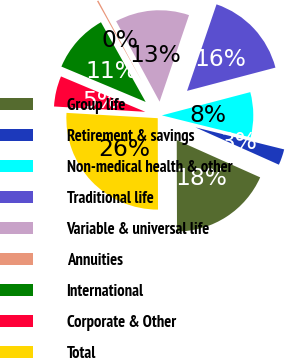Convert chart to OTSL. <chart><loc_0><loc_0><loc_500><loc_500><pie_chart><fcel>Group life<fcel>Retirement & savings<fcel>Non-medical health & other<fcel>Traditional life<fcel>Variable & universal life<fcel>Annuities<fcel>International<fcel>Corporate & Other<fcel>Total<nl><fcel>18.26%<fcel>2.82%<fcel>7.97%<fcel>15.68%<fcel>13.11%<fcel>0.25%<fcel>10.54%<fcel>5.4%<fcel>25.97%<nl></chart> 